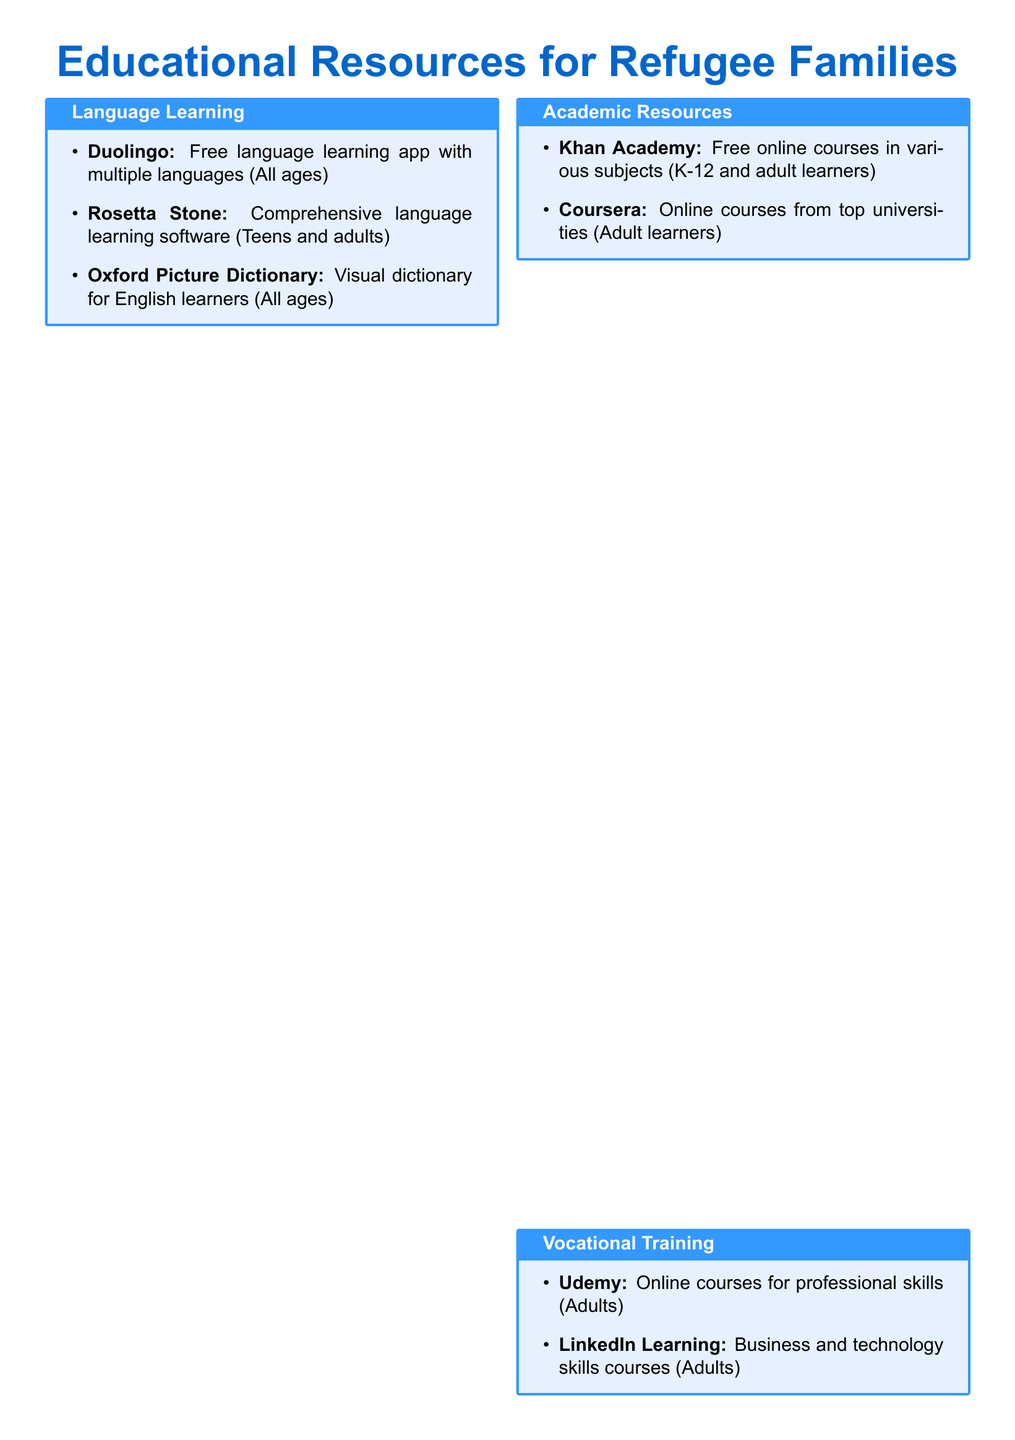what is the name of the free language learning app? The document lists Duolingo as a free language learning app suitable for all ages.
Answer: Duolingo which educational resource is tailored for children ages 2-8? The document specifies PBS Kids as an educational resource designed for children of this age group.
Answer: PBS Kids what type of online courses does Khan Academy offer? The document indicates that Khan Academy provides free online courses in various subjects suitable for K-12 and adult learners.
Answer: Various subjects which platform provides online courses from top universities? The document highlights Coursera as a platform offering online courses from prestigious institutions.
Answer: Coursera what is the target demographic for LinkedIn Learning? The document states that LinkedIn Learning courses are aimed at adults looking to acquire business and technology skills.
Answer: Adults which resource helps with U.S. citizenship learning? The document mentions USA Learns as a free online resource for learning English and U.S. citizenship, specifically for adult immigrants.
Answer: USA Learns how many educational resources are listed under Language Learning? The document enumerates three different resources in the Language Learning section.
Answer: Three what is the official guide for newcomers to Canada called? The document indicates that "Welcome to Canada" is the official guide for newcomers.
Answer: Welcome to Canada who can benefit from the Oxford Picture Dictionary? The document states that the Oxford Picture Dictionary is suitable for all ages, indicating its broad accessibility.
Answer: All ages 